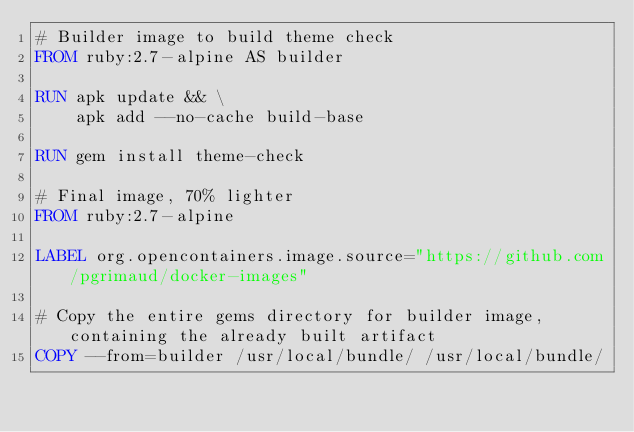Convert code to text. <code><loc_0><loc_0><loc_500><loc_500><_Dockerfile_># Builder image to build theme check
FROM ruby:2.7-alpine AS builder

RUN apk update && \
    apk add --no-cache build-base

RUN gem install theme-check

# Final image, 70% lighter
FROM ruby:2.7-alpine

LABEL org.opencontainers.image.source="https://github.com/pgrimaud/docker-images"

# Copy the entire gems directory for builder image, containing the already built artifact
COPY --from=builder /usr/local/bundle/ /usr/local/bundle/</code> 